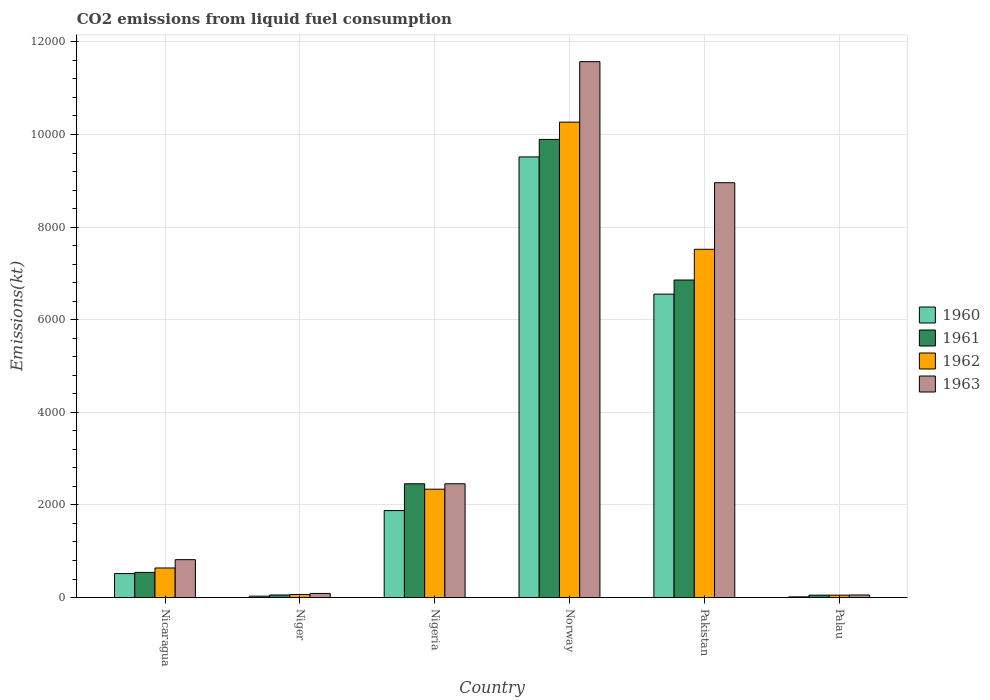How many different coloured bars are there?
Your answer should be compact. 4. Are the number of bars per tick equal to the number of legend labels?
Make the answer very short. Yes. Are the number of bars on each tick of the X-axis equal?
Offer a very short reply. Yes. How many bars are there on the 3rd tick from the left?
Your answer should be very brief. 4. What is the label of the 3rd group of bars from the left?
Provide a succinct answer. Nigeria. What is the amount of CO2 emitted in 1962 in Nicaragua?
Offer a terse response. 638.06. Across all countries, what is the maximum amount of CO2 emitted in 1960?
Offer a very short reply. 9515.86. Across all countries, what is the minimum amount of CO2 emitted in 1961?
Your response must be concise. 51.34. In which country was the amount of CO2 emitted in 1960 minimum?
Your answer should be very brief. Palau. What is the total amount of CO2 emitted in 1962 in the graph?
Give a very brief answer. 2.09e+04. What is the difference between the amount of CO2 emitted in 1961 in Nigeria and that in Pakistan?
Make the answer very short. -4400.4. What is the difference between the amount of CO2 emitted in 1963 in Nicaragua and the amount of CO2 emitted in 1962 in Palau?
Ensure brevity in your answer.  766.4. What is the average amount of CO2 emitted in 1963 per country?
Your answer should be very brief. 3991.53. What is the difference between the amount of CO2 emitted of/in 1963 and amount of CO2 emitted of/in 1961 in Niger?
Provide a succinct answer. 33. In how many countries, is the amount of CO2 emitted in 1962 greater than 10800 kt?
Your response must be concise. 0. What is the ratio of the amount of CO2 emitted in 1960 in Nicaragua to that in Nigeria?
Make the answer very short. 0.28. Is the amount of CO2 emitted in 1960 in Norway less than that in Pakistan?
Ensure brevity in your answer.  No. What is the difference between the highest and the second highest amount of CO2 emitted in 1961?
Make the answer very short. -4400.4. What is the difference between the highest and the lowest amount of CO2 emitted in 1962?
Your answer should be very brief. 1.02e+04. In how many countries, is the amount of CO2 emitted in 1961 greater than the average amount of CO2 emitted in 1961 taken over all countries?
Your answer should be compact. 2. Is the sum of the amount of CO2 emitted in 1963 in Nicaragua and Palau greater than the maximum amount of CO2 emitted in 1961 across all countries?
Make the answer very short. No. What does the 1st bar from the right in Nigeria represents?
Provide a short and direct response. 1963. Is it the case that in every country, the sum of the amount of CO2 emitted in 1962 and amount of CO2 emitted in 1963 is greater than the amount of CO2 emitted in 1961?
Offer a very short reply. Yes. How many countries are there in the graph?
Make the answer very short. 6. What is the difference between two consecutive major ticks on the Y-axis?
Offer a terse response. 2000. Does the graph contain any zero values?
Your answer should be compact. No. Does the graph contain grids?
Your response must be concise. Yes. Where does the legend appear in the graph?
Provide a succinct answer. Center right. How are the legend labels stacked?
Offer a very short reply. Vertical. What is the title of the graph?
Your answer should be compact. CO2 emissions from liquid fuel consumption. Does "1978" appear as one of the legend labels in the graph?
Provide a succinct answer. No. What is the label or title of the Y-axis?
Your answer should be very brief. Emissions(kt). What is the Emissions(kt) of 1960 in Nicaragua?
Give a very brief answer. 517.05. What is the Emissions(kt) in 1961 in Nicaragua?
Give a very brief answer. 542.72. What is the Emissions(kt) in 1962 in Nicaragua?
Your answer should be very brief. 638.06. What is the Emissions(kt) in 1963 in Nicaragua?
Your answer should be compact. 817.74. What is the Emissions(kt) in 1960 in Niger?
Your answer should be compact. 29.34. What is the Emissions(kt) in 1961 in Niger?
Your answer should be very brief. 55.01. What is the Emissions(kt) in 1962 in Niger?
Give a very brief answer. 66.01. What is the Emissions(kt) in 1963 in Niger?
Offer a terse response. 88.01. What is the Emissions(kt) of 1960 in Nigeria?
Keep it short and to the point. 1877.5. What is the Emissions(kt) in 1961 in Nigeria?
Keep it short and to the point. 2456.89. What is the Emissions(kt) in 1962 in Nigeria?
Ensure brevity in your answer.  2339.55. What is the Emissions(kt) in 1963 in Nigeria?
Your answer should be very brief. 2456.89. What is the Emissions(kt) of 1960 in Norway?
Give a very brief answer. 9515.86. What is the Emissions(kt) of 1961 in Norway?
Give a very brief answer. 9893.57. What is the Emissions(kt) of 1962 in Norway?
Offer a very short reply. 1.03e+04. What is the Emissions(kt) in 1963 in Norway?
Provide a short and direct response. 1.16e+04. What is the Emissions(kt) in 1960 in Pakistan?
Ensure brevity in your answer.  6552.93. What is the Emissions(kt) of 1961 in Pakistan?
Offer a terse response. 6857.29. What is the Emissions(kt) in 1962 in Pakistan?
Keep it short and to the point. 7521.02. What is the Emissions(kt) in 1963 in Pakistan?
Ensure brevity in your answer.  8958.48. What is the Emissions(kt) in 1960 in Palau?
Your answer should be very brief. 14.67. What is the Emissions(kt) of 1961 in Palau?
Offer a very short reply. 51.34. What is the Emissions(kt) of 1962 in Palau?
Make the answer very short. 51.34. What is the Emissions(kt) in 1963 in Palau?
Give a very brief answer. 55.01. Across all countries, what is the maximum Emissions(kt) in 1960?
Give a very brief answer. 9515.86. Across all countries, what is the maximum Emissions(kt) in 1961?
Make the answer very short. 9893.57. Across all countries, what is the maximum Emissions(kt) in 1962?
Keep it short and to the point. 1.03e+04. Across all countries, what is the maximum Emissions(kt) in 1963?
Ensure brevity in your answer.  1.16e+04. Across all countries, what is the minimum Emissions(kt) in 1960?
Your answer should be very brief. 14.67. Across all countries, what is the minimum Emissions(kt) of 1961?
Your answer should be very brief. 51.34. Across all countries, what is the minimum Emissions(kt) in 1962?
Offer a very short reply. 51.34. Across all countries, what is the minimum Emissions(kt) in 1963?
Your response must be concise. 55.01. What is the total Emissions(kt) of 1960 in the graph?
Offer a very short reply. 1.85e+04. What is the total Emissions(kt) of 1961 in the graph?
Make the answer very short. 1.99e+04. What is the total Emissions(kt) of 1962 in the graph?
Ensure brevity in your answer.  2.09e+04. What is the total Emissions(kt) in 1963 in the graph?
Provide a succinct answer. 2.39e+04. What is the difference between the Emissions(kt) of 1960 in Nicaragua and that in Niger?
Provide a succinct answer. 487.71. What is the difference between the Emissions(kt) in 1961 in Nicaragua and that in Niger?
Your answer should be very brief. 487.71. What is the difference between the Emissions(kt) of 1962 in Nicaragua and that in Niger?
Keep it short and to the point. 572.05. What is the difference between the Emissions(kt) in 1963 in Nicaragua and that in Niger?
Offer a very short reply. 729.73. What is the difference between the Emissions(kt) in 1960 in Nicaragua and that in Nigeria?
Offer a very short reply. -1360.46. What is the difference between the Emissions(kt) of 1961 in Nicaragua and that in Nigeria?
Your answer should be very brief. -1914.17. What is the difference between the Emissions(kt) in 1962 in Nicaragua and that in Nigeria?
Keep it short and to the point. -1701.49. What is the difference between the Emissions(kt) of 1963 in Nicaragua and that in Nigeria?
Your response must be concise. -1639.15. What is the difference between the Emissions(kt) in 1960 in Nicaragua and that in Norway?
Provide a short and direct response. -8998.82. What is the difference between the Emissions(kt) in 1961 in Nicaragua and that in Norway?
Give a very brief answer. -9350.85. What is the difference between the Emissions(kt) in 1962 in Nicaragua and that in Norway?
Your answer should be very brief. -9629.54. What is the difference between the Emissions(kt) in 1963 in Nicaragua and that in Norway?
Provide a succinct answer. -1.08e+04. What is the difference between the Emissions(kt) of 1960 in Nicaragua and that in Pakistan?
Ensure brevity in your answer.  -6035.88. What is the difference between the Emissions(kt) of 1961 in Nicaragua and that in Pakistan?
Keep it short and to the point. -6314.57. What is the difference between the Emissions(kt) in 1962 in Nicaragua and that in Pakistan?
Keep it short and to the point. -6882.96. What is the difference between the Emissions(kt) of 1963 in Nicaragua and that in Pakistan?
Keep it short and to the point. -8140.74. What is the difference between the Emissions(kt) of 1960 in Nicaragua and that in Palau?
Give a very brief answer. 502.38. What is the difference between the Emissions(kt) of 1961 in Nicaragua and that in Palau?
Make the answer very short. 491.38. What is the difference between the Emissions(kt) in 1962 in Nicaragua and that in Palau?
Keep it short and to the point. 586.72. What is the difference between the Emissions(kt) of 1963 in Nicaragua and that in Palau?
Ensure brevity in your answer.  762.74. What is the difference between the Emissions(kt) in 1960 in Niger and that in Nigeria?
Ensure brevity in your answer.  -1848.17. What is the difference between the Emissions(kt) of 1961 in Niger and that in Nigeria?
Make the answer very short. -2401.89. What is the difference between the Emissions(kt) of 1962 in Niger and that in Nigeria?
Ensure brevity in your answer.  -2273.54. What is the difference between the Emissions(kt) in 1963 in Niger and that in Nigeria?
Offer a terse response. -2368.88. What is the difference between the Emissions(kt) of 1960 in Niger and that in Norway?
Your response must be concise. -9486.53. What is the difference between the Emissions(kt) of 1961 in Niger and that in Norway?
Your answer should be very brief. -9838.56. What is the difference between the Emissions(kt) in 1962 in Niger and that in Norway?
Make the answer very short. -1.02e+04. What is the difference between the Emissions(kt) in 1963 in Niger and that in Norway?
Offer a terse response. -1.15e+04. What is the difference between the Emissions(kt) in 1960 in Niger and that in Pakistan?
Ensure brevity in your answer.  -6523.59. What is the difference between the Emissions(kt) in 1961 in Niger and that in Pakistan?
Your answer should be compact. -6802.28. What is the difference between the Emissions(kt) of 1962 in Niger and that in Pakistan?
Give a very brief answer. -7455.01. What is the difference between the Emissions(kt) of 1963 in Niger and that in Pakistan?
Offer a very short reply. -8870.47. What is the difference between the Emissions(kt) in 1960 in Niger and that in Palau?
Your answer should be very brief. 14.67. What is the difference between the Emissions(kt) in 1961 in Niger and that in Palau?
Ensure brevity in your answer.  3.67. What is the difference between the Emissions(kt) in 1962 in Niger and that in Palau?
Your answer should be compact. 14.67. What is the difference between the Emissions(kt) in 1963 in Niger and that in Palau?
Provide a succinct answer. 33. What is the difference between the Emissions(kt) in 1960 in Nigeria and that in Norway?
Offer a very short reply. -7638.36. What is the difference between the Emissions(kt) in 1961 in Nigeria and that in Norway?
Provide a succinct answer. -7436.68. What is the difference between the Emissions(kt) in 1962 in Nigeria and that in Norway?
Offer a very short reply. -7928.05. What is the difference between the Emissions(kt) in 1963 in Nigeria and that in Norway?
Give a very brief answer. -9116.16. What is the difference between the Emissions(kt) of 1960 in Nigeria and that in Pakistan?
Make the answer very short. -4675.43. What is the difference between the Emissions(kt) in 1961 in Nigeria and that in Pakistan?
Ensure brevity in your answer.  -4400.4. What is the difference between the Emissions(kt) in 1962 in Nigeria and that in Pakistan?
Offer a terse response. -5181.47. What is the difference between the Emissions(kt) in 1963 in Nigeria and that in Pakistan?
Provide a short and direct response. -6501.59. What is the difference between the Emissions(kt) of 1960 in Nigeria and that in Palau?
Provide a short and direct response. 1862.84. What is the difference between the Emissions(kt) in 1961 in Nigeria and that in Palau?
Keep it short and to the point. 2405.55. What is the difference between the Emissions(kt) in 1962 in Nigeria and that in Palau?
Make the answer very short. 2288.21. What is the difference between the Emissions(kt) in 1963 in Nigeria and that in Palau?
Offer a terse response. 2401.89. What is the difference between the Emissions(kt) of 1960 in Norway and that in Pakistan?
Provide a short and direct response. 2962.94. What is the difference between the Emissions(kt) of 1961 in Norway and that in Pakistan?
Provide a short and direct response. 3036.28. What is the difference between the Emissions(kt) in 1962 in Norway and that in Pakistan?
Provide a short and direct response. 2746.58. What is the difference between the Emissions(kt) in 1963 in Norway and that in Pakistan?
Ensure brevity in your answer.  2614.57. What is the difference between the Emissions(kt) of 1960 in Norway and that in Palau?
Your answer should be compact. 9501.2. What is the difference between the Emissions(kt) in 1961 in Norway and that in Palau?
Provide a succinct answer. 9842.23. What is the difference between the Emissions(kt) of 1962 in Norway and that in Palau?
Your answer should be very brief. 1.02e+04. What is the difference between the Emissions(kt) in 1963 in Norway and that in Palau?
Offer a very short reply. 1.15e+04. What is the difference between the Emissions(kt) of 1960 in Pakistan and that in Palau?
Ensure brevity in your answer.  6538.26. What is the difference between the Emissions(kt) of 1961 in Pakistan and that in Palau?
Give a very brief answer. 6805.95. What is the difference between the Emissions(kt) in 1962 in Pakistan and that in Palau?
Make the answer very short. 7469.68. What is the difference between the Emissions(kt) of 1963 in Pakistan and that in Palau?
Ensure brevity in your answer.  8903.48. What is the difference between the Emissions(kt) in 1960 in Nicaragua and the Emissions(kt) in 1961 in Niger?
Your response must be concise. 462.04. What is the difference between the Emissions(kt) of 1960 in Nicaragua and the Emissions(kt) of 1962 in Niger?
Make the answer very short. 451.04. What is the difference between the Emissions(kt) of 1960 in Nicaragua and the Emissions(kt) of 1963 in Niger?
Your response must be concise. 429.04. What is the difference between the Emissions(kt) of 1961 in Nicaragua and the Emissions(kt) of 1962 in Niger?
Make the answer very short. 476.71. What is the difference between the Emissions(kt) in 1961 in Nicaragua and the Emissions(kt) in 1963 in Niger?
Give a very brief answer. 454.71. What is the difference between the Emissions(kt) in 1962 in Nicaragua and the Emissions(kt) in 1963 in Niger?
Make the answer very short. 550.05. What is the difference between the Emissions(kt) in 1960 in Nicaragua and the Emissions(kt) in 1961 in Nigeria?
Your response must be concise. -1939.84. What is the difference between the Emissions(kt) of 1960 in Nicaragua and the Emissions(kt) of 1962 in Nigeria?
Offer a very short reply. -1822.5. What is the difference between the Emissions(kt) in 1960 in Nicaragua and the Emissions(kt) in 1963 in Nigeria?
Your answer should be very brief. -1939.84. What is the difference between the Emissions(kt) in 1961 in Nicaragua and the Emissions(kt) in 1962 in Nigeria?
Keep it short and to the point. -1796.83. What is the difference between the Emissions(kt) in 1961 in Nicaragua and the Emissions(kt) in 1963 in Nigeria?
Your answer should be very brief. -1914.17. What is the difference between the Emissions(kt) of 1962 in Nicaragua and the Emissions(kt) of 1963 in Nigeria?
Offer a very short reply. -1818.83. What is the difference between the Emissions(kt) of 1960 in Nicaragua and the Emissions(kt) of 1961 in Norway?
Your response must be concise. -9376.52. What is the difference between the Emissions(kt) of 1960 in Nicaragua and the Emissions(kt) of 1962 in Norway?
Your answer should be compact. -9750.55. What is the difference between the Emissions(kt) of 1960 in Nicaragua and the Emissions(kt) of 1963 in Norway?
Make the answer very short. -1.11e+04. What is the difference between the Emissions(kt) of 1961 in Nicaragua and the Emissions(kt) of 1962 in Norway?
Give a very brief answer. -9724.88. What is the difference between the Emissions(kt) of 1961 in Nicaragua and the Emissions(kt) of 1963 in Norway?
Make the answer very short. -1.10e+04. What is the difference between the Emissions(kt) in 1962 in Nicaragua and the Emissions(kt) in 1963 in Norway?
Make the answer very short. -1.09e+04. What is the difference between the Emissions(kt) in 1960 in Nicaragua and the Emissions(kt) in 1961 in Pakistan?
Offer a very short reply. -6340.24. What is the difference between the Emissions(kt) of 1960 in Nicaragua and the Emissions(kt) of 1962 in Pakistan?
Keep it short and to the point. -7003.97. What is the difference between the Emissions(kt) in 1960 in Nicaragua and the Emissions(kt) in 1963 in Pakistan?
Your answer should be compact. -8441.43. What is the difference between the Emissions(kt) of 1961 in Nicaragua and the Emissions(kt) of 1962 in Pakistan?
Give a very brief answer. -6978.3. What is the difference between the Emissions(kt) in 1961 in Nicaragua and the Emissions(kt) in 1963 in Pakistan?
Provide a succinct answer. -8415.76. What is the difference between the Emissions(kt) of 1962 in Nicaragua and the Emissions(kt) of 1963 in Pakistan?
Offer a very short reply. -8320.42. What is the difference between the Emissions(kt) of 1960 in Nicaragua and the Emissions(kt) of 1961 in Palau?
Provide a succinct answer. 465.71. What is the difference between the Emissions(kt) in 1960 in Nicaragua and the Emissions(kt) in 1962 in Palau?
Offer a very short reply. 465.71. What is the difference between the Emissions(kt) in 1960 in Nicaragua and the Emissions(kt) in 1963 in Palau?
Your answer should be very brief. 462.04. What is the difference between the Emissions(kt) in 1961 in Nicaragua and the Emissions(kt) in 1962 in Palau?
Your response must be concise. 491.38. What is the difference between the Emissions(kt) in 1961 in Nicaragua and the Emissions(kt) in 1963 in Palau?
Keep it short and to the point. 487.71. What is the difference between the Emissions(kt) in 1962 in Nicaragua and the Emissions(kt) in 1963 in Palau?
Ensure brevity in your answer.  583.05. What is the difference between the Emissions(kt) of 1960 in Niger and the Emissions(kt) of 1961 in Nigeria?
Give a very brief answer. -2427.55. What is the difference between the Emissions(kt) of 1960 in Niger and the Emissions(kt) of 1962 in Nigeria?
Your answer should be compact. -2310.21. What is the difference between the Emissions(kt) of 1960 in Niger and the Emissions(kt) of 1963 in Nigeria?
Offer a terse response. -2427.55. What is the difference between the Emissions(kt) of 1961 in Niger and the Emissions(kt) of 1962 in Nigeria?
Your response must be concise. -2284.54. What is the difference between the Emissions(kt) in 1961 in Niger and the Emissions(kt) in 1963 in Nigeria?
Offer a terse response. -2401.89. What is the difference between the Emissions(kt) in 1962 in Niger and the Emissions(kt) in 1963 in Nigeria?
Your answer should be compact. -2390.88. What is the difference between the Emissions(kt) in 1960 in Niger and the Emissions(kt) in 1961 in Norway?
Keep it short and to the point. -9864.23. What is the difference between the Emissions(kt) in 1960 in Niger and the Emissions(kt) in 1962 in Norway?
Your answer should be very brief. -1.02e+04. What is the difference between the Emissions(kt) of 1960 in Niger and the Emissions(kt) of 1963 in Norway?
Offer a very short reply. -1.15e+04. What is the difference between the Emissions(kt) in 1961 in Niger and the Emissions(kt) in 1962 in Norway?
Provide a short and direct response. -1.02e+04. What is the difference between the Emissions(kt) of 1961 in Niger and the Emissions(kt) of 1963 in Norway?
Your answer should be very brief. -1.15e+04. What is the difference between the Emissions(kt) in 1962 in Niger and the Emissions(kt) in 1963 in Norway?
Make the answer very short. -1.15e+04. What is the difference between the Emissions(kt) of 1960 in Niger and the Emissions(kt) of 1961 in Pakistan?
Make the answer very short. -6827.95. What is the difference between the Emissions(kt) of 1960 in Niger and the Emissions(kt) of 1962 in Pakistan?
Give a very brief answer. -7491.68. What is the difference between the Emissions(kt) of 1960 in Niger and the Emissions(kt) of 1963 in Pakistan?
Give a very brief answer. -8929.15. What is the difference between the Emissions(kt) of 1961 in Niger and the Emissions(kt) of 1962 in Pakistan?
Give a very brief answer. -7466.01. What is the difference between the Emissions(kt) of 1961 in Niger and the Emissions(kt) of 1963 in Pakistan?
Your answer should be compact. -8903.48. What is the difference between the Emissions(kt) of 1962 in Niger and the Emissions(kt) of 1963 in Pakistan?
Ensure brevity in your answer.  -8892.48. What is the difference between the Emissions(kt) in 1960 in Niger and the Emissions(kt) in 1961 in Palau?
Give a very brief answer. -22. What is the difference between the Emissions(kt) of 1960 in Niger and the Emissions(kt) of 1962 in Palau?
Make the answer very short. -22. What is the difference between the Emissions(kt) of 1960 in Niger and the Emissions(kt) of 1963 in Palau?
Make the answer very short. -25.67. What is the difference between the Emissions(kt) of 1961 in Niger and the Emissions(kt) of 1962 in Palau?
Your answer should be very brief. 3.67. What is the difference between the Emissions(kt) of 1961 in Niger and the Emissions(kt) of 1963 in Palau?
Keep it short and to the point. 0. What is the difference between the Emissions(kt) in 1962 in Niger and the Emissions(kt) in 1963 in Palau?
Ensure brevity in your answer.  11. What is the difference between the Emissions(kt) of 1960 in Nigeria and the Emissions(kt) of 1961 in Norway?
Offer a very short reply. -8016.06. What is the difference between the Emissions(kt) in 1960 in Nigeria and the Emissions(kt) in 1962 in Norway?
Make the answer very short. -8390.1. What is the difference between the Emissions(kt) of 1960 in Nigeria and the Emissions(kt) of 1963 in Norway?
Your response must be concise. -9695.55. What is the difference between the Emissions(kt) of 1961 in Nigeria and the Emissions(kt) of 1962 in Norway?
Keep it short and to the point. -7810.71. What is the difference between the Emissions(kt) of 1961 in Nigeria and the Emissions(kt) of 1963 in Norway?
Provide a succinct answer. -9116.16. What is the difference between the Emissions(kt) of 1962 in Nigeria and the Emissions(kt) of 1963 in Norway?
Your answer should be very brief. -9233.51. What is the difference between the Emissions(kt) in 1960 in Nigeria and the Emissions(kt) in 1961 in Pakistan?
Make the answer very short. -4979.79. What is the difference between the Emissions(kt) in 1960 in Nigeria and the Emissions(kt) in 1962 in Pakistan?
Make the answer very short. -5643.51. What is the difference between the Emissions(kt) of 1960 in Nigeria and the Emissions(kt) of 1963 in Pakistan?
Your answer should be very brief. -7080.98. What is the difference between the Emissions(kt) of 1961 in Nigeria and the Emissions(kt) of 1962 in Pakistan?
Make the answer very short. -5064.13. What is the difference between the Emissions(kt) in 1961 in Nigeria and the Emissions(kt) in 1963 in Pakistan?
Your response must be concise. -6501.59. What is the difference between the Emissions(kt) in 1962 in Nigeria and the Emissions(kt) in 1963 in Pakistan?
Keep it short and to the point. -6618.94. What is the difference between the Emissions(kt) in 1960 in Nigeria and the Emissions(kt) in 1961 in Palau?
Offer a very short reply. 1826.17. What is the difference between the Emissions(kt) of 1960 in Nigeria and the Emissions(kt) of 1962 in Palau?
Your answer should be very brief. 1826.17. What is the difference between the Emissions(kt) in 1960 in Nigeria and the Emissions(kt) in 1963 in Palau?
Give a very brief answer. 1822.5. What is the difference between the Emissions(kt) of 1961 in Nigeria and the Emissions(kt) of 1962 in Palau?
Provide a succinct answer. 2405.55. What is the difference between the Emissions(kt) in 1961 in Nigeria and the Emissions(kt) in 1963 in Palau?
Make the answer very short. 2401.89. What is the difference between the Emissions(kt) of 1962 in Nigeria and the Emissions(kt) of 1963 in Palau?
Provide a short and direct response. 2284.54. What is the difference between the Emissions(kt) of 1960 in Norway and the Emissions(kt) of 1961 in Pakistan?
Keep it short and to the point. 2658.57. What is the difference between the Emissions(kt) in 1960 in Norway and the Emissions(kt) in 1962 in Pakistan?
Your response must be concise. 1994.85. What is the difference between the Emissions(kt) in 1960 in Norway and the Emissions(kt) in 1963 in Pakistan?
Your answer should be very brief. 557.38. What is the difference between the Emissions(kt) in 1961 in Norway and the Emissions(kt) in 1962 in Pakistan?
Provide a short and direct response. 2372.55. What is the difference between the Emissions(kt) in 1961 in Norway and the Emissions(kt) in 1963 in Pakistan?
Provide a succinct answer. 935.09. What is the difference between the Emissions(kt) in 1962 in Norway and the Emissions(kt) in 1963 in Pakistan?
Offer a terse response. 1309.12. What is the difference between the Emissions(kt) of 1960 in Norway and the Emissions(kt) of 1961 in Palau?
Your answer should be very brief. 9464.53. What is the difference between the Emissions(kt) of 1960 in Norway and the Emissions(kt) of 1962 in Palau?
Ensure brevity in your answer.  9464.53. What is the difference between the Emissions(kt) of 1960 in Norway and the Emissions(kt) of 1963 in Palau?
Keep it short and to the point. 9460.86. What is the difference between the Emissions(kt) in 1961 in Norway and the Emissions(kt) in 1962 in Palau?
Make the answer very short. 9842.23. What is the difference between the Emissions(kt) in 1961 in Norway and the Emissions(kt) in 1963 in Palau?
Keep it short and to the point. 9838.56. What is the difference between the Emissions(kt) of 1962 in Norway and the Emissions(kt) of 1963 in Palau?
Ensure brevity in your answer.  1.02e+04. What is the difference between the Emissions(kt) in 1960 in Pakistan and the Emissions(kt) in 1961 in Palau?
Your answer should be compact. 6501.59. What is the difference between the Emissions(kt) in 1960 in Pakistan and the Emissions(kt) in 1962 in Palau?
Your answer should be compact. 6501.59. What is the difference between the Emissions(kt) in 1960 in Pakistan and the Emissions(kt) in 1963 in Palau?
Give a very brief answer. 6497.92. What is the difference between the Emissions(kt) of 1961 in Pakistan and the Emissions(kt) of 1962 in Palau?
Your answer should be compact. 6805.95. What is the difference between the Emissions(kt) in 1961 in Pakistan and the Emissions(kt) in 1963 in Palau?
Keep it short and to the point. 6802.28. What is the difference between the Emissions(kt) of 1962 in Pakistan and the Emissions(kt) of 1963 in Palau?
Offer a terse response. 7466.01. What is the average Emissions(kt) of 1960 per country?
Provide a succinct answer. 3084.56. What is the average Emissions(kt) in 1961 per country?
Keep it short and to the point. 3309.47. What is the average Emissions(kt) of 1962 per country?
Give a very brief answer. 3480.59. What is the average Emissions(kt) of 1963 per country?
Make the answer very short. 3991.53. What is the difference between the Emissions(kt) of 1960 and Emissions(kt) of 1961 in Nicaragua?
Your answer should be very brief. -25.67. What is the difference between the Emissions(kt) in 1960 and Emissions(kt) in 1962 in Nicaragua?
Your answer should be very brief. -121.01. What is the difference between the Emissions(kt) of 1960 and Emissions(kt) of 1963 in Nicaragua?
Your response must be concise. -300.69. What is the difference between the Emissions(kt) of 1961 and Emissions(kt) of 1962 in Nicaragua?
Your response must be concise. -95.34. What is the difference between the Emissions(kt) of 1961 and Emissions(kt) of 1963 in Nicaragua?
Offer a terse response. -275.02. What is the difference between the Emissions(kt) in 1962 and Emissions(kt) in 1963 in Nicaragua?
Offer a terse response. -179.68. What is the difference between the Emissions(kt) of 1960 and Emissions(kt) of 1961 in Niger?
Make the answer very short. -25.67. What is the difference between the Emissions(kt) in 1960 and Emissions(kt) in 1962 in Niger?
Keep it short and to the point. -36.67. What is the difference between the Emissions(kt) of 1960 and Emissions(kt) of 1963 in Niger?
Give a very brief answer. -58.67. What is the difference between the Emissions(kt) of 1961 and Emissions(kt) of 1962 in Niger?
Keep it short and to the point. -11. What is the difference between the Emissions(kt) in 1961 and Emissions(kt) in 1963 in Niger?
Give a very brief answer. -33. What is the difference between the Emissions(kt) of 1962 and Emissions(kt) of 1963 in Niger?
Offer a terse response. -22. What is the difference between the Emissions(kt) of 1960 and Emissions(kt) of 1961 in Nigeria?
Ensure brevity in your answer.  -579.39. What is the difference between the Emissions(kt) in 1960 and Emissions(kt) in 1962 in Nigeria?
Your response must be concise. -462.04. What is the difference between the Emissions(kt) in 1960 and Emissions(kt) in 1963 in Nigeria?
Offer a terse response. -579.39. What is the difference between the Emissions(kt) in 1961 and Emissions(kt) in 1962 in Nigeria?
Make the answer very short. 117.34. What is the difference between the Emissions(kt) of 1961 and Emissions(kt) of 1963 in Nigeria?
Your answer should be compact. 0. What is the difference between the Emissions(kt) in 1962 and Emissions(kt) in 1963 in Nigeria?
Your response must be concise. -117.34. What is the difference between the Emissions(kt) of 1960 and Emissions(kt) of 1961 in Norway?
Offer a very short reply. -377.7. What is the difference between the Emissions(kt) in 1960 and Emissions(kt) in 1962 in Norway?
Provide a short and direct response. -751.74. What is the difference between the Emissions(kt) of 1960 and Emissions(kt) of 1963 in Norway?
Your response must be concise. -2057.19. What is the difference between the Emissions(kt) of 1961 and Emissions(kt) of 1962 in Norway?
Offer a terse response. -374.03. What is the difference between the Emissions(kt) in 1961 and Emissions(kt) in 1963 in Norway?
Provide a short and direct response. -1679.49. What is the difference between the Emissions(kt) of 1962 and Emissions(kt) of 1963 in Norway?
Your response must be concise. -1305.45. What is the difference between the Emissions(kt) in 1960 and Emissions(kt) in 1961 in Pakistan?
Your answer should be compact. -304.36. What is the difference between the Emissions(kt) in 1960 and Emissions(kt) in 1962 in Pakistan?
Your response must be concise. -968.09. What is the difference between the Emissions(kt) in 1960 and Emissions(kt) in 1963 in Pakistan?
Ensure brevity in your answer.  -2405.55. What is the difference between the Emissions(kt) in 1961 and Emissions(kt) in 1962 in Pakistan?
Ensure brevity in your answer.  -663.73. What is the difference between the Emissions(kt) in 1961 and Emissions(kt) in 1963 in Pakistan?
Your answer should be very brief. -2101.19. What is the difference between the Emissions(kt) of 1962 and Emissions(kt) of 1963 in Pakistan?
Give a very brief answer. -1437.46. What is the difference between the Emissions(kt) of 1960 and Emissions(kt) of 1961 in Palau?
Make the answer very short. -36.67. What is the difference between the Emissions(kt) in 1960 and Emissions(kt) in 1962 in Palau?
Your answer should be compact. -36.67. What is the difference between the Emissions(kt) in 1960 and Emissions(kt) in 1963 in Palau?
Offer a terse response. -40.34. What is the difference between the Emissions(kt) of 1961 and Emissions(kt) of 1962 in Palau?
Offer a very short reply. 0. What is the difference between the Emissions(kt) of 1961 and Emissions(kt) of 1963 in Palau?
Provide a succinct answer. -3.67. What is the difference between the Emissions(kt) of 1962 and Emissions(kt) of 1963 in Palau?
Give a very brief answer. -3.67. What is the ratio of the Emissions(kt) in 1960 in Nicaragua to that in Niger?
Provide a succinct answer. 17.62. What is the ratio of the Emissions(kt) of 1961 in Nicaragua to that in Niger?
Provide a short and direct response. 9.87. What is the ratio of the Emissions(kt) of 1962 in Nicaragua to that in Niger?
Provide a short and direct response. 9.67. What is the ratio of the Emissions(kt) of 1963 in Nicaragua to that in Niger?
Your answer should be compact. 9.29. What is the ratio of the Emissions(kt) in 1960 in Nicaragua to that in Nigeria?
Offer a terse response. 0.28. What is the ratio of the Emissions(kt) of 1961 in Nicaragua to that in Nigeria?
Make the answer very short. 0.22. What is the ratio of the Emissions(kt) of 1962 in Nicaragua to that in Nigeria?
Your response must be concise. 0.27. What is the ratio of the Emissions(kt) of 1963 in Nicaragua to that in Nigeria?
Provide a succinct answer. 0.33. What is the ratio of the Emissions(kt) in 1960 in Nicaragua to that in Norway?
Give a very brief answer. 0.05. What is the ratio of the Emissions(kt) in 1961 in Nicaragua to that in Norway?
Your answer should be compact. 0.05. What is the ratio of the Emissions(kt) in 1962 in Nicaragua to that in Norway?
Offer a terse response. 0.06. What is the ratio of the Emissions(kt) of 1963 in Nicaragua to that in Norway?
Keep it short and to the point. 0.07. What is the ratio of the Emissions(kt) in 1960 in Nicaragua to that in Pakistan?
Your answer should be very brief. 0.08. What is the ratio of the Emissions(kt) of 1961 in Nicaragua to that in Pakistan?
Ensure brevity in your answer.  0.08. What is the ratio of the Emissions(kt) in 1962 in Nicaragua to that in Pakistan?
Offer a terse response. 0.08. What is the ratio of the Emissions(kt) in 1963 in Nicaragua to that in Pakistan?
Make the answer very short. 0.09. What is the ratio of the Emissions(kt) in 1960 in Nicaragua to that in Palau?
Make the answer very short. 35.25. What is the ratio of the Emissions(kt) of 1961 in Nicaragua to that in Palau?
Your answer should be very brief. 10.57. What is the ratio of the Emissions(kt) in 1962 in Nicaragua to that in Palau?
Ensure brevity in your answer.  12.43. What is the ratio of the Emissions(kt) of 1963 in Nicaragua to that in Palau?
Your answer should be compact. 14.87. What is the ratio of the Emissions(kt) in 1960 in Niger to that in Nigeria?
Keep it short and to the point. 0.02. What is the ratio of the Emissions(kt) in 1961 in Niger to that in Nigeria?
Your response must be concise. 0.02. What is the ratio of the Emissions(kt) in 1962 in Niger to that in Nigeria?
Provide a short and direct response. 0.03. What is the ratio of the Emissions(kt) of 1963 in Niger to that in Nigeria?
Ensure brevity in your answer.  0.04. What is the ratio of the Emissions(kt) of 1960 in Niger to that in Norway?
Provide a short and direct response. 0. What is the ratio of the Emissions(kt) of 1961 in Niger to that in Norway?
Make the answer very short. 0.01. What is the ratio of the Emissions(kt) in 1962 in Niger to that in Norway?
Give a very brief answer. 0.01. What is the ratio of the Emissions(kt) in 1963 in Niger to that in Norway?
Ensure brevity in your answer.  0.01. What is the ratio of the Emissions(kt) in 1960 in Niger to that in Pakistan?
Make the answer very short. 0. What is the ratio of the Emissions(kt) in 1961 in Niger to that in Pakistan?
Your response must be concise. 0.01. What is the ratio of the Emissions(kt) in 1962 in Niger to that in Pakistan?
Ensure brevity in your answer.  0.01. What is the ratio of the Emissions(kt) in 1963 in Niger to that in Pakistan?
Ensure brevity in your answer.  0.01. What is the ratio of the Emissions(kt) in 1961 in Niger to that in Palau?
Give a very brief answer. 1.07. What is the ratio of the Emissions(kt) of 1962 in Niger to that in Palau?
Provide a short and direct response. 1.29. What is the ratio of the Emissions(kt) in 1960 in Nigeria to that in Norway?
Provide a short and direct response. 0.2. What is the ratio of the Emissions(kt) of 1961 in Nigeria to that in Norway?
Your answer should be very brief. 0.25. What is the ratio of the Emissions(kt) in 1962 in Nigeria to that in Norway?
Your response must be concise. 0.23. What is the ratio of the Emissions(kt) of 1963 in Nigeria to that in Norway?
Your answer should be compact. 0.21. What is the ratio of the Emissions(kt) in 1960 in Nigeria to that in Pakistan?
Offer a very short reply. 0.29. What is the ratio of the Emissions(kt) of 1961 in Nigeria to that in Pakistan?
Your response must be concise. 0.36. What is the ratio of the Emissions(kt) of 1962 in Nigeria to that in Pakistan?
Make the answer very short. 0.31. What is the ratio of the Emissions(kt) in 1963 in Nigeria to that in Pakistan?
Your answer should be compact. 0.27. What is the ratio of the Emissions(kt) of 1960 in Nigeria to that in Palau?
Ensure brevity in your answer.  128. What is the ratio of the Emissions(kt) of 1961 in Nigeria to that in Palau?
Offer a terse response. 47.86. What is the ratio of the Emissions(kt) of 1962 in Nigeria to that in Palau?
Offer a very short reply. 45.57. What is the ratio of the Emissions(kt) of 1963 in Nigeria to that in Palau?
Ensure brevity in your answer.  44.67. What is the ratio of the Emissions(kt) of 1960 in Norway to that in Pakistan?
Provide a succinct answer. 1.45. What is the ratio of the Emissions(kt) of 1961 in Norway to that in Pakistan?
Your answer should be compact. 1.44. What is the ratio of the Emissions(kt) in 1962 in Norway to that in Pakistan?
Provide a short and direct response. 1.37. What is the ratio of the Emissions(kt) of 1963 in Norway to that in Pakistan?
Your answer should be very brief. 1.29. What is the ratio of the Emissions(kt) of 1960 in Norway to that in Palau?
Your answer should be very brief. 648.75. What is the ratio of the Emissions(kt) in 1961 in Norway to that in Palau?
Provide a short and direct response. 192.71. What is the ratio of the Emissions(kt) in 1962 in Norway to that in Palau?
Ensure brevity in your answer.  200. What is the ratio of the Emissions(kt) in 1963 in Norway to that in Palau?
Your answer should be very brief. 210.4. What is the ratio of the Emissions(kt) of 1960 in Pakistan to that in Palau?
Give a very brief answer. 446.75. What is the ratio of the Emissions(kt) of 1961 in Pakistan to that in Palau?
Offer a terse response. 133.57. What is the ratio of the Emissions(kt) of 1962 in Pakistan to that in Palau?
Make the answer very short. 146.5. What is the ratio of the Emissions(kt) of 1963 in Pakistan to that in Palau?
Your answer should be very brief. 162.87. What is the difference between the highest and the second highest Emissions(kt) in 1960?
Provide a succinct answer. 2962.94. What is the difference between the highest and the second highest Emissions(kt) in 1961?
Make the answer very short. 3036.28. What is the difference between the highest and the second highest Emissions(kt) of 1962?
Make the answer very short. 2746.58. What is the difference between the highest and the second highest Emissions(kt) in 1963?
Provide a succinct answer. 2614.57. What is the difference between the highest and the lowest Emissions(kt) of 1960?
Provide a succinct answer. 9501.2. What is the difference between the highest and the lowest Emissions(kt) of 1961?
Keep it short and to the point. 9842.23. What is the difference between the highest and the lowest Emissions(kt) of 1962?
Your answer should be very brief. 1.02e+04. What is the difference between the highest and the lowest Emissions(kt) of 1963?
Your answer should be very brief. 1.15e+04. 